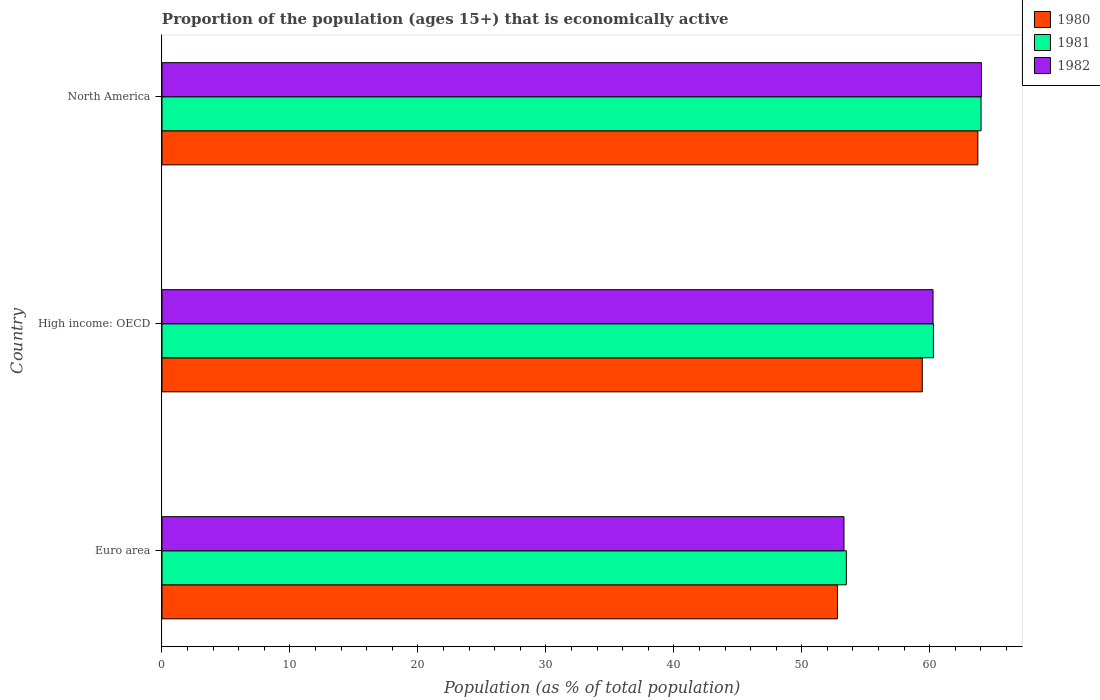How many groups of bars are there?
Give a very brief answer. 3. Are the number of bars on each tick of the Y-axis equal?
Provide a succinct answer. Yes. How many bars are there on the 1st tick from the top?
Your response must be concise. 3. How many bars are there on the 1st tick from the bottom?
Your response must be concise. 3. What is the label of the 2nd group of bars from the top?
Your answer should be compact. High income: OECD. What is the proportion of the population that is economically active in 1982 in High income: OECD?
Make the answer very short. 60.25. Across all countries, what is the maximum proportion of the population that is economically active in 1982?
Give a very brief answer. 64.04. Across all countries, what is the minimum proportion of the population that is economically active in 1980?
Your response must be concise. 52.79. In which country was the proportion of the population that is economically active in 1981 maximum?
Provide a short and direct response. North America. In which country was the proportion of the population that is economically active in 1982 minimum?
Provide a succinct answer. Euro area. What is the total proportion of the population that is economically active in 1982 in the graph?
Ensure brevity in your answer.  177.59. What is the difference between the proportion of the population that is economically active in 1981 in Euro area and that in North America?
Give a very brief answer. -10.53. What is the difference between the proportion of the population that is economically active in 1980 in Euro area and the proportion of the population that is economically active in 1981 in High income: OECD?
Your answer should be very brief. -7.5. What is the average proportion of the population that is economically active in 1982 per country?
Ensure brevity in your answer.  59.2. What is the difference between the proportion of the population that is economically active in 1981 and proportion of the population that is economically active in 1980 in North America?
Give a very brief answer. 0.25. What is the ratio of the proportion of the population that is economically active in 1980 in Euro area to that in North America?
Provide a short and direct response. 0.83. Is the proportion of the population that is economically active in 1980 in High income: OECD less than that in North America?
Provide a succinct answer. Yes. Is the difference between the proportion of the population that is economically active in 1981 in High income: OECD and North America greater than the difference between the proportion of the population that is economically active in 1980 in High income: OECD and North America?
Provide a short and direct response. Yes. What is the difference between the highest and the second highest proportion of the population that is economically active in 1982?
Offer a terse response. 3.78. What is the difference between the highest and the lowest proportion of the population that is economically active in 1982?
Provide a short and direct response. 10.74. Is the sum of the proportion of the population that is economically active in 1982 in Euro area and High income: OECD greater than the maximum proportion of the population that is economically active in 1981 across all countries?
Make the answer very short. Yes. Is it the case that in every country, the sum of the proportion of the population that is economically active in 1981 and proportion of the population that is economically active in 1980 is greater than the proportion of the population that is economically active in 1982?
Offer a very short reply. Yes. How many bars are there?
Offer a very short reply. 9. How many countries are there in the graph?
Your answer should be very brief. 3. How many legend labels are there?
Your answer should be very brief. 3. What is the title of the graph?
Your response must be concise. Proportion of the population (ages 15+) that is economically active. What is the label or title of the X-axis?
Ensure brevity in your answer.  Population (as % of total population). What is the label or title of the Y-axis?
Offer a very short reply. Country. What is the Population (as % of total population) in 1980 in Euro area?
Your answer should be very brief. 52.79. What is the Population (as % of total population) in 1981 in Euro area?
Ensure brevity in your answer.  53.48. What is the Population (as % of total population) in 1982 in Euro area?
Keep it short and to the point. 53.3. What is the Population (as % of total population) in 1980 in High income: OECD?
Provide a succinct answer. 59.41. What is the Population (as % of total population) of 1981 in High income: OECD?
Make the answer very short. 60.29. What is the Population (as % of total population) in 1982 in High income: OECD?
Your answer should be compact. 60.25. What is the Population (as % of total population) of 1980 in North America?
Your answer should be compact. 63.76. What is the Population (as % of total population) in 1981 in North America?
Provide a short and direct response. 64.01. What is the Population (as % of total population) of 1982 in North America?
Provide a succinct answer. 64.04. Across all countries, what is the maximum Population (as % of total population) in 1980?
Offer a very short reply. 63.76. Across all countries, what is the maximum Population (as % of total population) of 1981?
Provide a succinct answer. 64.01. Across all countries, what is the maximum Population (as % of total population) in 1982?
Offer a very short reply. 64.04. Across all countries, what is the minimum Population (as % of total population) of 1980?
Make the answer very short. 52.79. Across all countries, what is the minimum Population (as % of total population) of 1981?
Offer a terse response. 53.48. Across all countries, what is the minimum Population (as % of total population) of 1982?
Offer a very short reply. 53.3. What is the total Population (as % of total population) in 1980 in the graph?
Offer a terse response. 175.96. What is the total Population (as % of total population) of 1981 in the graph?
Your response must be concise. 177.77. What is the total Population (as % of total population) in 1982 in the graph?
Your response must be concise. 177.59. What is the difference between the Population (as % of total population) of 1980 in Euro area and that in High income: OECD?
Your answer should be very brief. -6.63. What is the difference between the Population (as % of total population) of 1981 in Euro area and that in High income: OECD?
Offer a very short reply. -6.81. What is the difference between the Population (as % of total population) of 1982 in Euro area and that in High income: OECD?
Make the answer very short. -6.96. What is the difference between the Population (as % of total population) of 1980 in Euro area and that in North America?
Give a very brief answer. -10.97. What is the difference between the Population (as % of total population) of 1981 in Euro area and that in North America?
Provide a short and direct response. -10.53. What is the difference between the Population (as % of total population) of 1982 in Euro area and that in North America?
Make the answer very short. -10.74. What is the difference between the Population (as % of total population) of 1980 in High income: OECD and that in North America?
Your answer should be very brief. -4.34. What is the difference between the Population (as % of total population) of 1981 in High income: OECD and that in North America?
Offer a terse response. -3.72. What is the difference between the Population (as % of total population) in 1982 in High income: OECD and that in North America?
Provide a succinct answer. -3.78. What is the difference between the Population (as % of total population) in 1980 in Euro area and the Population (as % of total population) in 1981 in High income: OECD?
Offer a terse response. -7.5. What is the difference between the Population (as % of total population) of 1980 in Euro area and the Population (as % of total population) of 1982 in High income: OECD?
Provide a succinct answer. -7.47. What is the difference between the Population (as % of total population) of 1981 in Euro area and the Population (as % of total population) of 1982 in High income: OECD?
Offer a terse response. -6.78. What is the difference between the Population (as % of total population) of 1980 in Euro area and the Population (as % of total population) of 1981 in North America?
Give a very brief answer. -11.22. What is the difference between the Population (as % of total population) in 1980 in Euro area and the Population (as % of total population) in 1982 in North America?
Give a very brief answer. -11.25. What is the difference between the Population (as % of total population) in 1981 in Euro area and the Population (as % of total population) in 1982 in North America?
Your answer should be compact. -10.56. What is the difference between the Population (as % of total population) in 1980 in High income: OECD and the Population (as % of total population) in 1981 in North America?
Ensure brevity in your answer.  -4.59. What is the difference between the Population (as % of total population) of 1980 in High income: OECD and the Population (as % of total population) of 1982 in North America?
Provide a succinct answer. -4.62. What is the difference between the Population (as % of total population) in 1981 in High income: OECD and the Population (as % of total population) in 1982 in North America?
Make the answer very short. -3.75. What is the average Population (as % of total population) of 1980 per country?
Give a very brief answer. 58.65. What is the average Population (as % of total population) in 1981 per country?
Offer a terse response. 59.26. What is the average Population (as % of total population) in 1982 per country?
Your answer should be compact. 59.2. What is the difference between the Population (as % of total population) in 1980 and Population (as % of total population) in 1981 in Euro area?
Give a very brief answer. -0.69. What is the difference between the Population (as % of total population) in 1980 and Population (as % of total population) in 1982 in Euro area?
Provide a succinct answer. -0.51. What is the difference between the Population (as % of total population) in 1981 and Population (as % of total population) in 1982 in Euro area?
Keep it short and to the point. 0.18. What is the difference between the Population (as % of total population) in 1980 and Population (as % of total population) in 1981 in High income: OECD?
Provide a succinct answer. -0.87. What is the difference between the Population (as % of total population) in 1980 and Population (as % of total population) in 1982 in High income: OECD?
Keep it short and to the point. -0.84. What is the difference between the Population (as % of total population) in 1981 and Population (as % of total population) in 1982 in High income: OECD?
Your response must be concise. 0.03. What is the difference between the Population (as % of total population) in 1980 and Population (as % of total population) in 1981 in North America?
Make the answer very short. -0.25. What is the difference between the Population (as % of total population) of 1980 and Population (as % of total population) of 1982 in North America?
Offer a terse response. -0.28. What is the difference between the Population (as % of total population) in 1981 and Population (as % of total population) in 1982 in North America?
Your response must be concise. -0.03. What is the ratio of the Population (as % of total population) in 1980 in Euro area to that in High income: OECD?
Keep it short and to the point. 0.89. What is the ratio of the Population (as % of total population) in 1981 in Euro area to that in High income: OECD?
Make the answer very short. 0.89. What is the ratio of the Population (as % of total population) in 1982 in Euro area to that in High income: OECD?
Offer a terse response. 0.88. What is the ratio of the Population (as % of total population) of 1980 in Euro area to that in North America?
Your answer should be very brief. 0.83. What is the ratio of the Population (as % of total population) in 1981 in Euro area to that in North America?
Ensure brevity in your answer.  0.84. What is the ratio of the Population (as % of total population) in 1982 in Euro area to that in North America?
Keep it short and to the point. 0.83. What is the ratio of the Population (as % of total population) of 1980 in High income: OECD to that in North America?
Keep it short and to the point. 0.93. What is the ratio of the Population (as % of total population) of 1981 in High income: OECD to that in North America?
Offer a very short reply. 0.94. What is the ratio of the Population (as % of total population) of 1982 in High income: OECD to that in North America?
Keep it short and to the point. 0.94. What is the difference between the highest and the second highest Population (as % of total population) in 1980?
Provide a succinct answer. 4.34. What is the difference between the highest and the second highest Population (as % of total population) of 1981?
Provide a succinct answer. 3.72. What is the difference between the highest and the second highest Population (as % of total population) in 1982?
Provide a succinct answer. 3.78. What is the difference between the highest and the lowest Population (as % of total population) of 1980?
Make the answer very short. 10.97. What is the difference between the highest and the lowest Population (as % of total population) in 1981?
Your answer should be very brief. 10.53. What is the difference between the highest and the lowest Population (as % of total population) of 1982?
Your response must be concise. 10.74. 